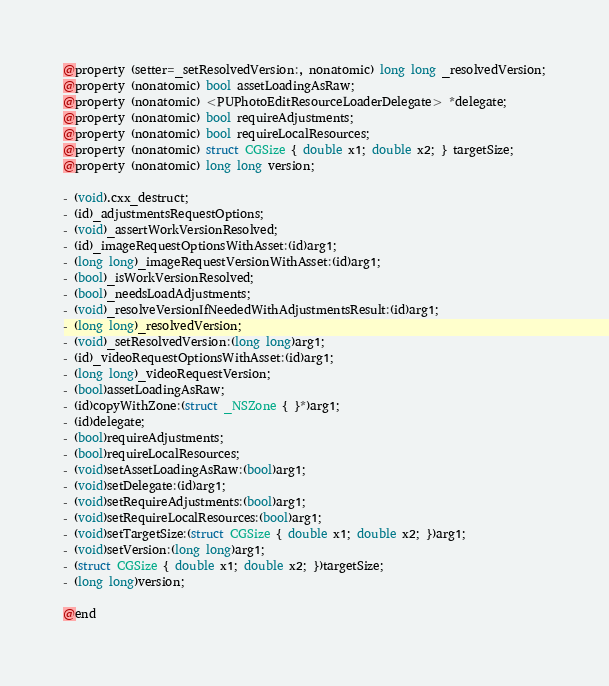<code> <loc_0><loc_0><loc_500><loc_500><_C_>@property (setter=_setResolvedVersion:, nonatomic) long long _resolvedVersion;
@property (nonatomic) bool assetLoadingAsRaw;
@property (nonatomic) <PUPhotoEditResourceLoaderDelegate> *delegate;
@property (nonatomic) bool requireAdjustments;
@property (nonatomic) bool requireLocalResources;
@property (nonatomic) struct CGSize { double x1; double x2; } targetSize;
@property (nonatomic) long long version;

- (void).cxx_destruct;
- (id)_adjustmentsRequestOptions;
- (void)_assertWorkVersionResolved;
- (id)_imageRequestOptionsWithAsset:(id)arg1;
- (long long)_imageRequestVersionWithAsset:(id)arg1;
- (bool)_isWorkVersionResolved;
- (bool)_needsLoadAdjustments;
- (void)_resolveVersionIfNeededWithAdjustmentsResult:(id)arg1;
- (long long)_resolvedVersion;
- (void)_setResolvedVersion:(long long)arg1;
- (id)_videoRequestOptionsWithAsset:(id)arg1;
- (long long)_videoRequestVersion;
- (bool)assetLoadingAsRaw;
- (id)copyWithZone:(struct _NSZone { }*)arg1;
- (id)delegate;
- (bool)requireAdjustments;
- (bool)requireLocalResources;
- (void)setAssetLoadingAsRaw:(bool)arg1;
- (void)setDelegate:(id)arg1;
- (void)setRequireAdjustments:(bool)arg1;
- (void)setRequireLocalResources:(bool)arg1;
- (void)setTargetSize:(struct CGSize { double x1; double x2; })arg1;
- (void)setVersion:(long long)arg1;
- (struct CGSize { double x1; double x2; })targetSize;
- (long long)version;

@end
</code> 